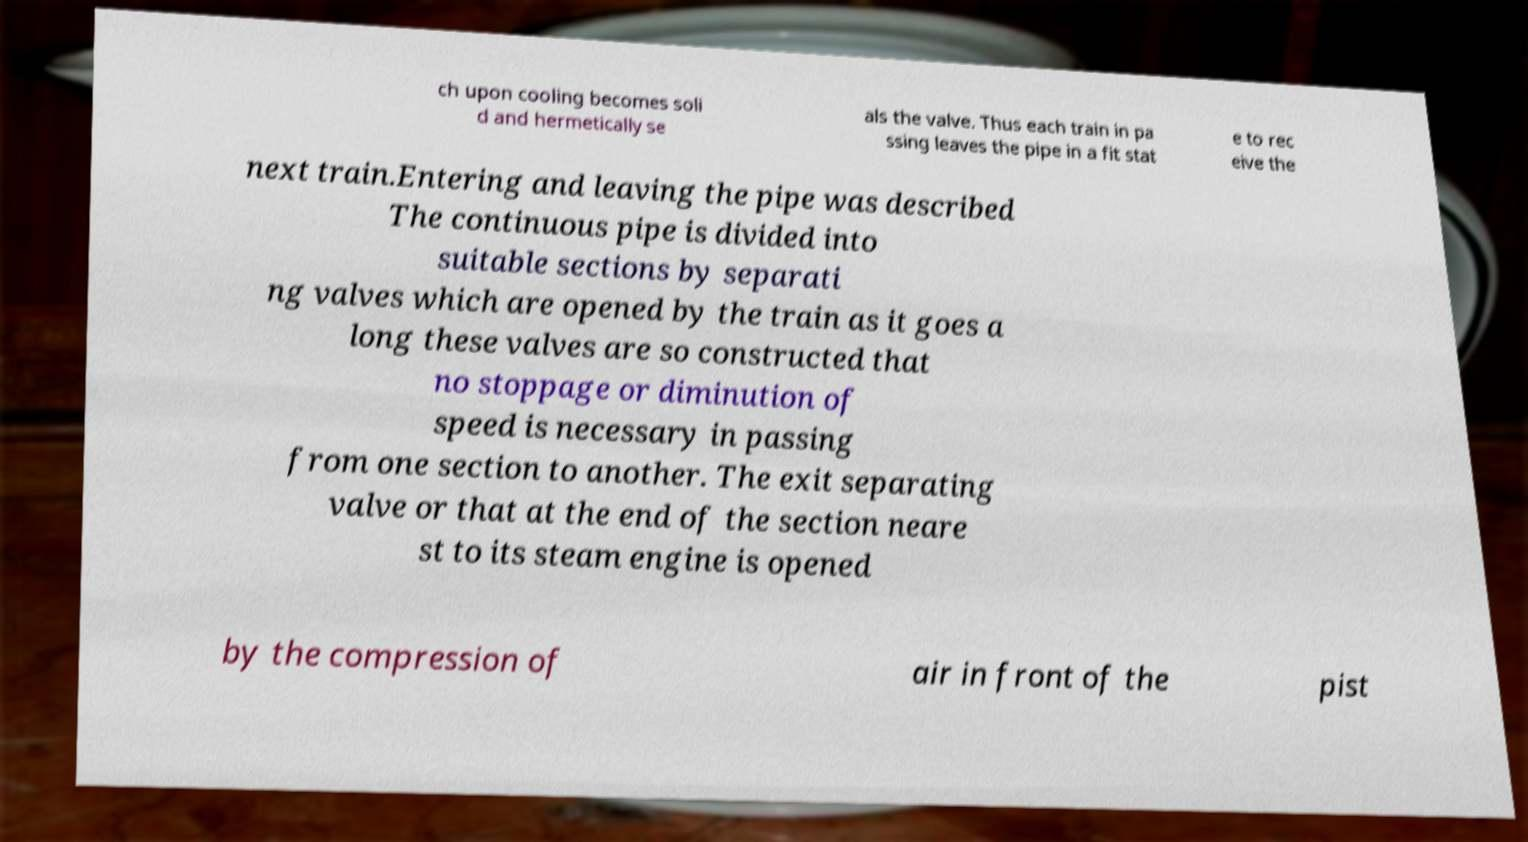What messages or text are displayed in this image? I need them in a readable, typed format. ch upon cooling becomes soli d and hermetically se als the valve. Thus each train in pa ssing leaves the pipe in a fit stat e to rec eive the next train.Entering and leaving the pipe was described The continuous pipe is divided into suitable sections by separati ng valves which are opened by the train as it goes a long these valves are so constructed that no stoppage or diminution of speed is necessary in passing from one section to another. The exit separating valve or that at the end of the section neare st to its steam engine is opened by the compression of air in front of the pist 